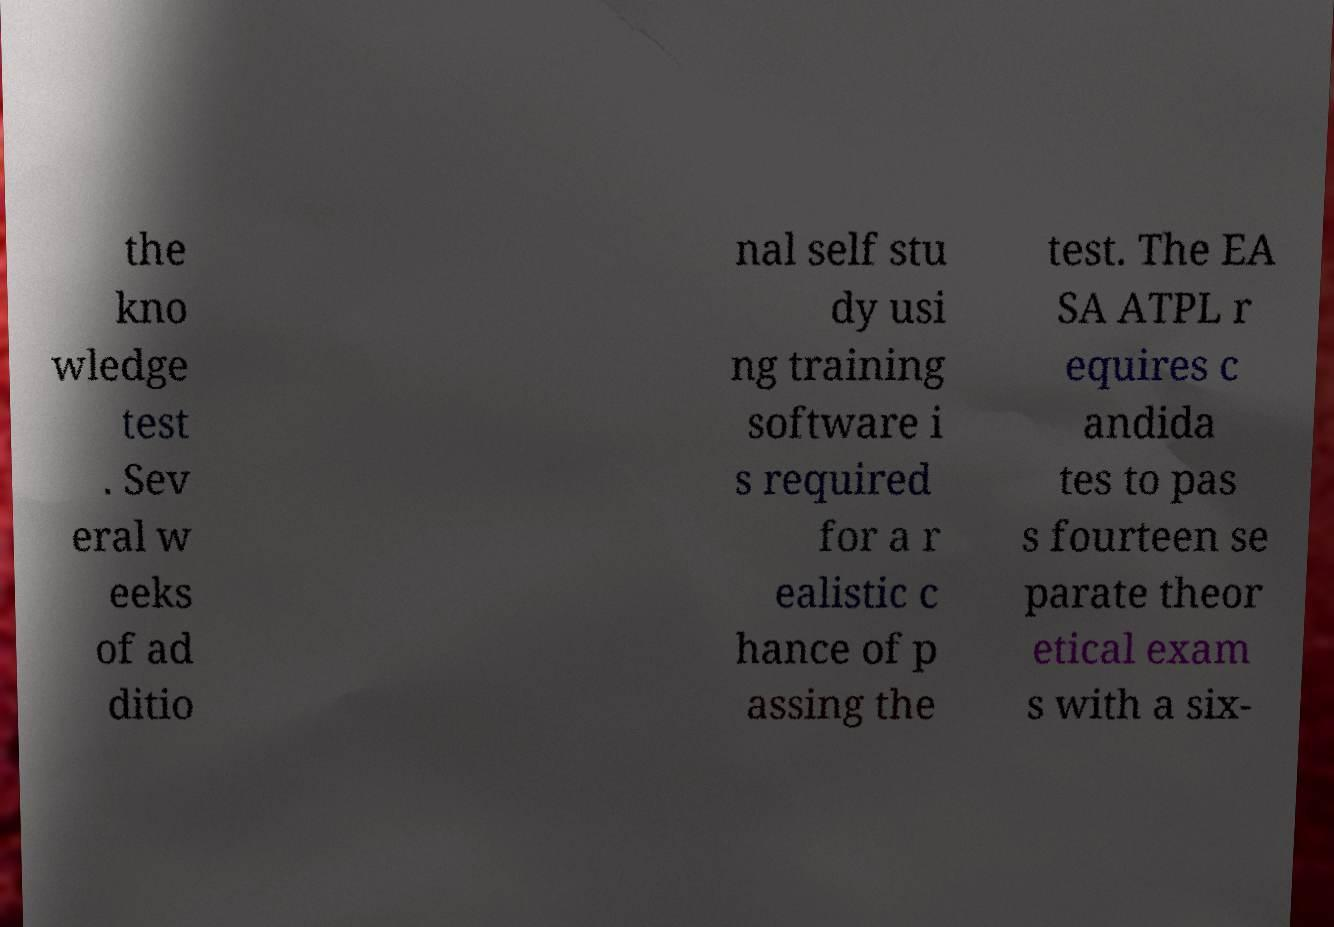Can you read and provide the text displayed in the image?This photo seems to have some interesting text. Can you extract and type it out for me? the kno wledge test . Sev eral w eeks of ad ditio nal self stu dy usi ng training software i s required for a r ealistic c hance of p assing the test. The EA SA ATPL r equires c andida tes to pas s fourteen se parate theor etical exam s with a six- 